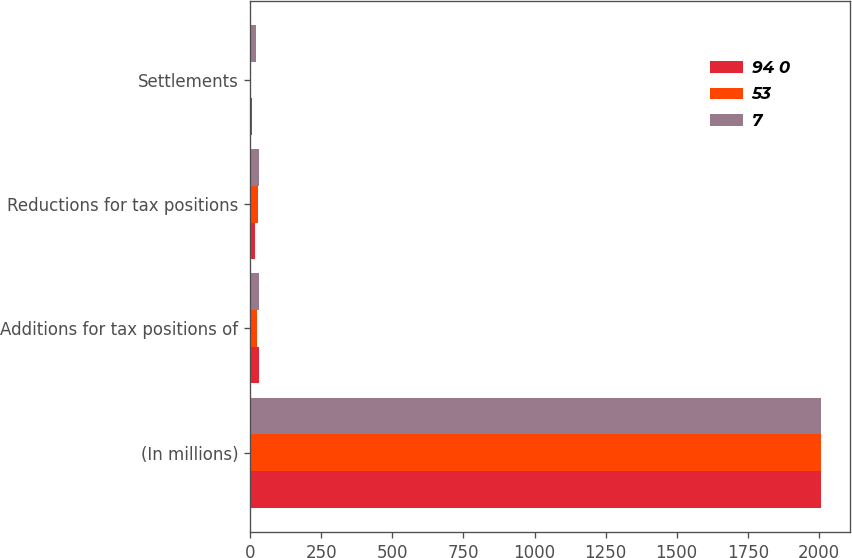Convert chart to OTSL. <chart><loc_0><loc_0><loc_500><loc_500><stacked_bar_chart><ecel><fcel>(In millions)<fcel>Additions for tax positions of<fcel>Reductions for tax positions<fcel>Settlements<nl><fcel>94 0<fcel>2009<fcel>30<fcel>15<fcel>7<nl><fcel>53<fcel>2008<fcel>24<fcel>26<fcel>1<nl><fcel>7<fcel>2007<fcel>30<fcel>30<fcel>19<nl></chart> 